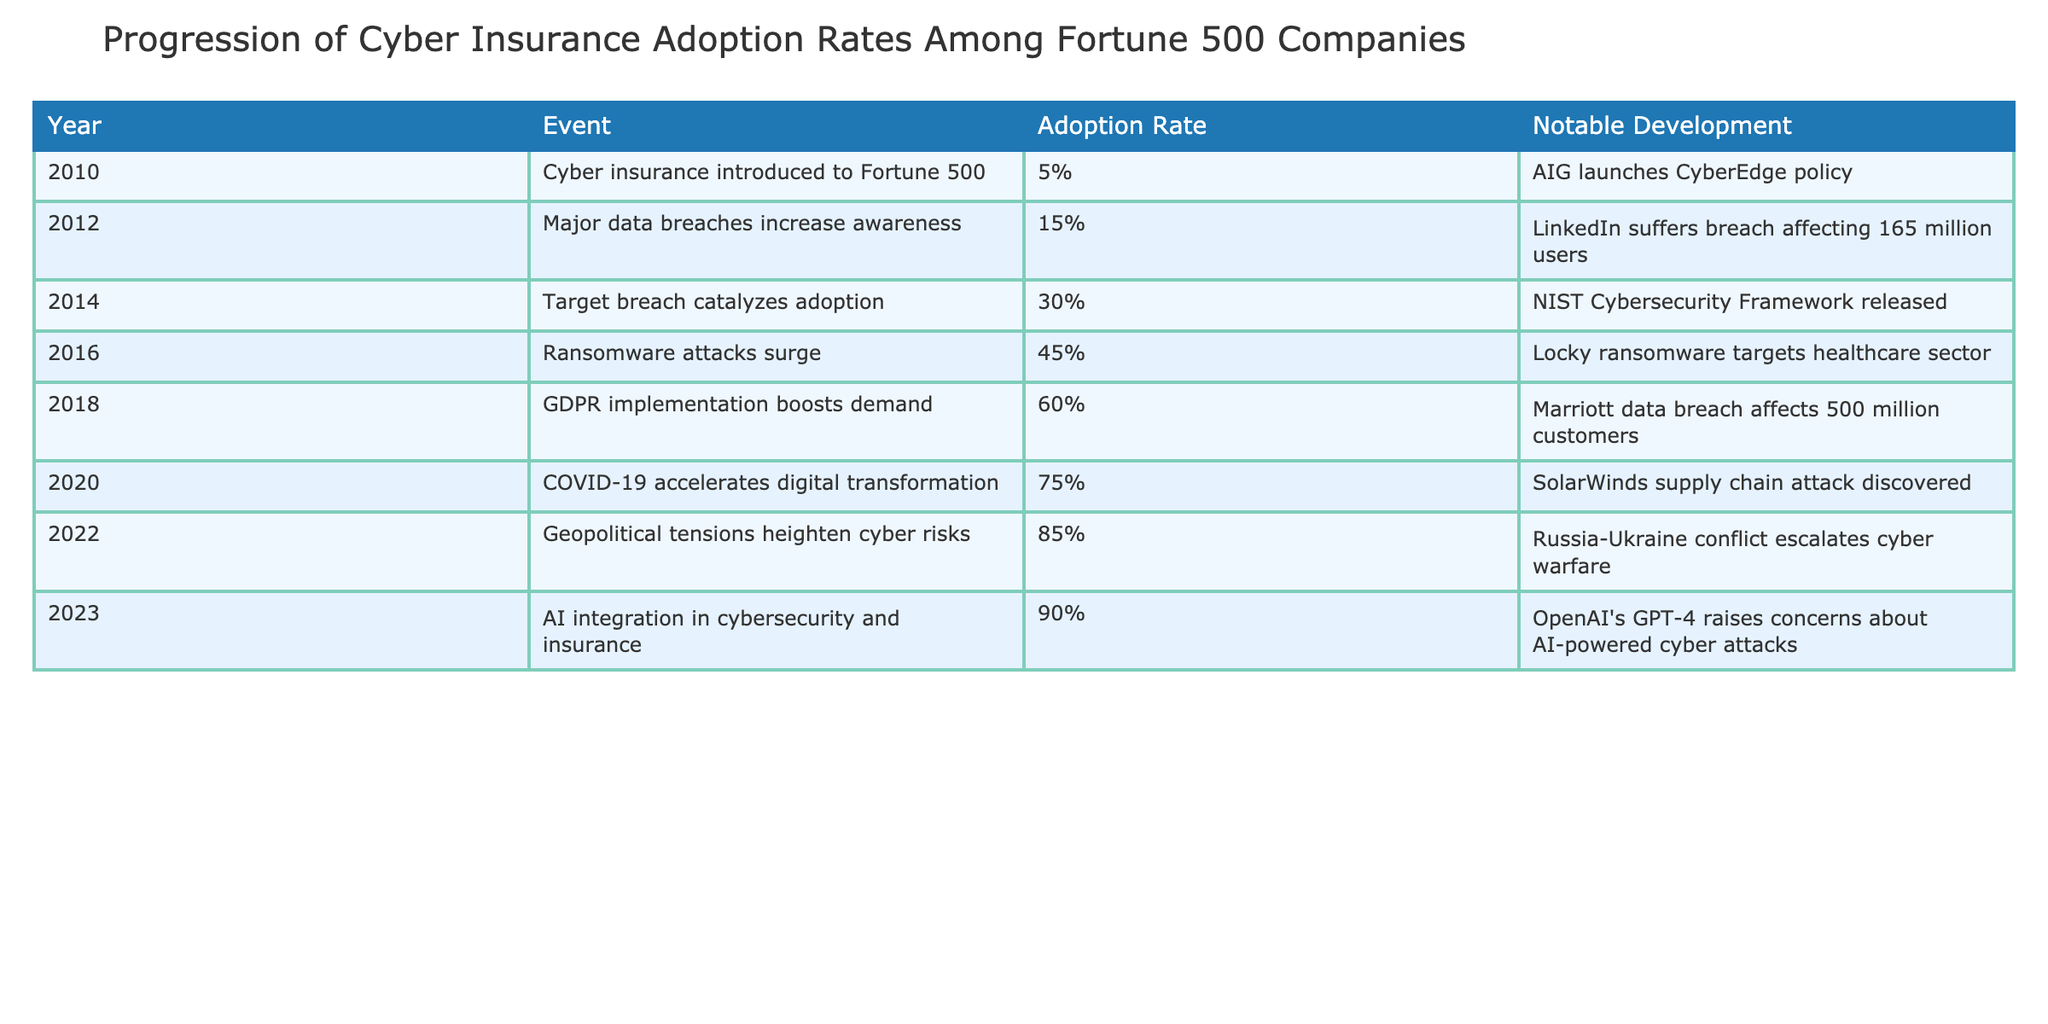What year did cyber insurance first get introduced to Fortune 500 companies? The table indicates that cyber insurance was introduced in 2010.
Answer: 2010 What was the adoption rate of cyber insurance in 2014? According to the table, the adoption rate in 2014 was 30%.
Answer: 30% What notable development coincided with the highest adoption rate, which was 90%? The table shows that the notable development in 2023, when the adoption rate was 90%, was related to OpenAI's GPT-4 and concerns about AI-powered cyber attacks.
Answer: OpenAI's GPT-4 raises concerns about AI-powered cyber attacks Is it true that the adoption rate reached 75% before the implementation of GDPR in 2018? Looking at the table, the adoption rate was 75% in 2020, which is after the GDPR implementation in 2018; thus, the statement is false.
Answer: No What is the difference in adoption rate between 2020 and 2012? The adoption rate in 2020 is 75%, and in 2012 it was 15%. The difference is calculated as 75% - 15% = 60%.
Answer: 60% What was the percentage increase in adoption rates from 2016 to 2022? The adoption rate in 2016 was 45% and in 2022 it was 85%, so the percentage increase is 85% - 45% = 40%.
Answer: 40% Which event in 2018 caused a significant increase in awareness about cyber insurance? The table notes that the implementation of GDPR in 2018 significantly boosted demand for cyber insurance.
Answer: Implementation of GDPR What notable event occurred in the same year as the largest increase in adoption rate of 45%? In 2016, the notable event was a surge in ransomware attacks, particularly the Locky ransomware targeting the healthcare sector.
Answer: Locky ransomware targets healthcare sector What has been the trend in adoption rates from 2010 to 2023? By observing the table, the adoption rates show a consistent upward trend from 5% in 2010 to 90% in 2023, indicating increasing acceptance of cyber insurance among Fortune 500 companies.
Answer: Consistently increasing trend 